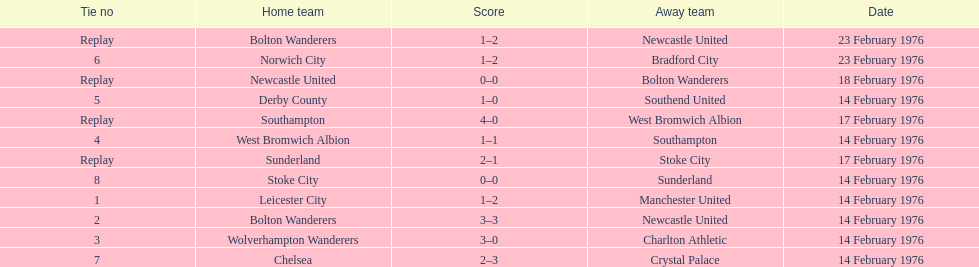Which teams took part in matches on the same day as the leicester city and manchester united game? Bolton Wanderers, Newcastle United. 